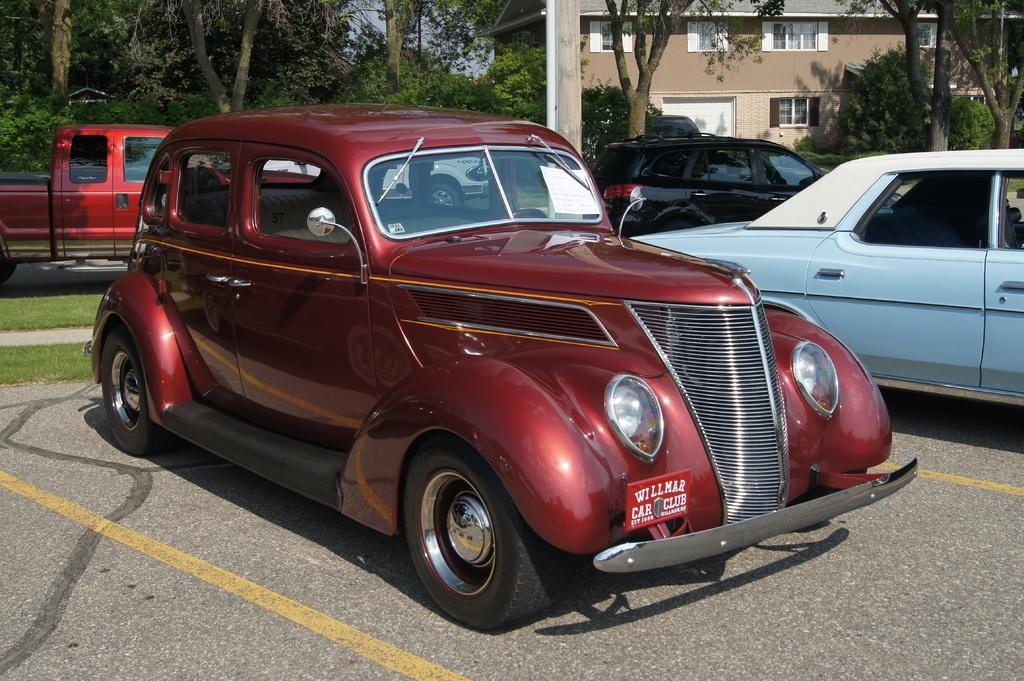How many vehicles are present in the image? There are four vehicles in the image. Can you describe the car in the center of the image? There is a maroon color car in the center of the image. What can be seen in the background of the image? There is a building and trees in the background of the image. What type of coat is the dog wearing in the image? There is no dog present in the image, and therefore no coat can be observed. 